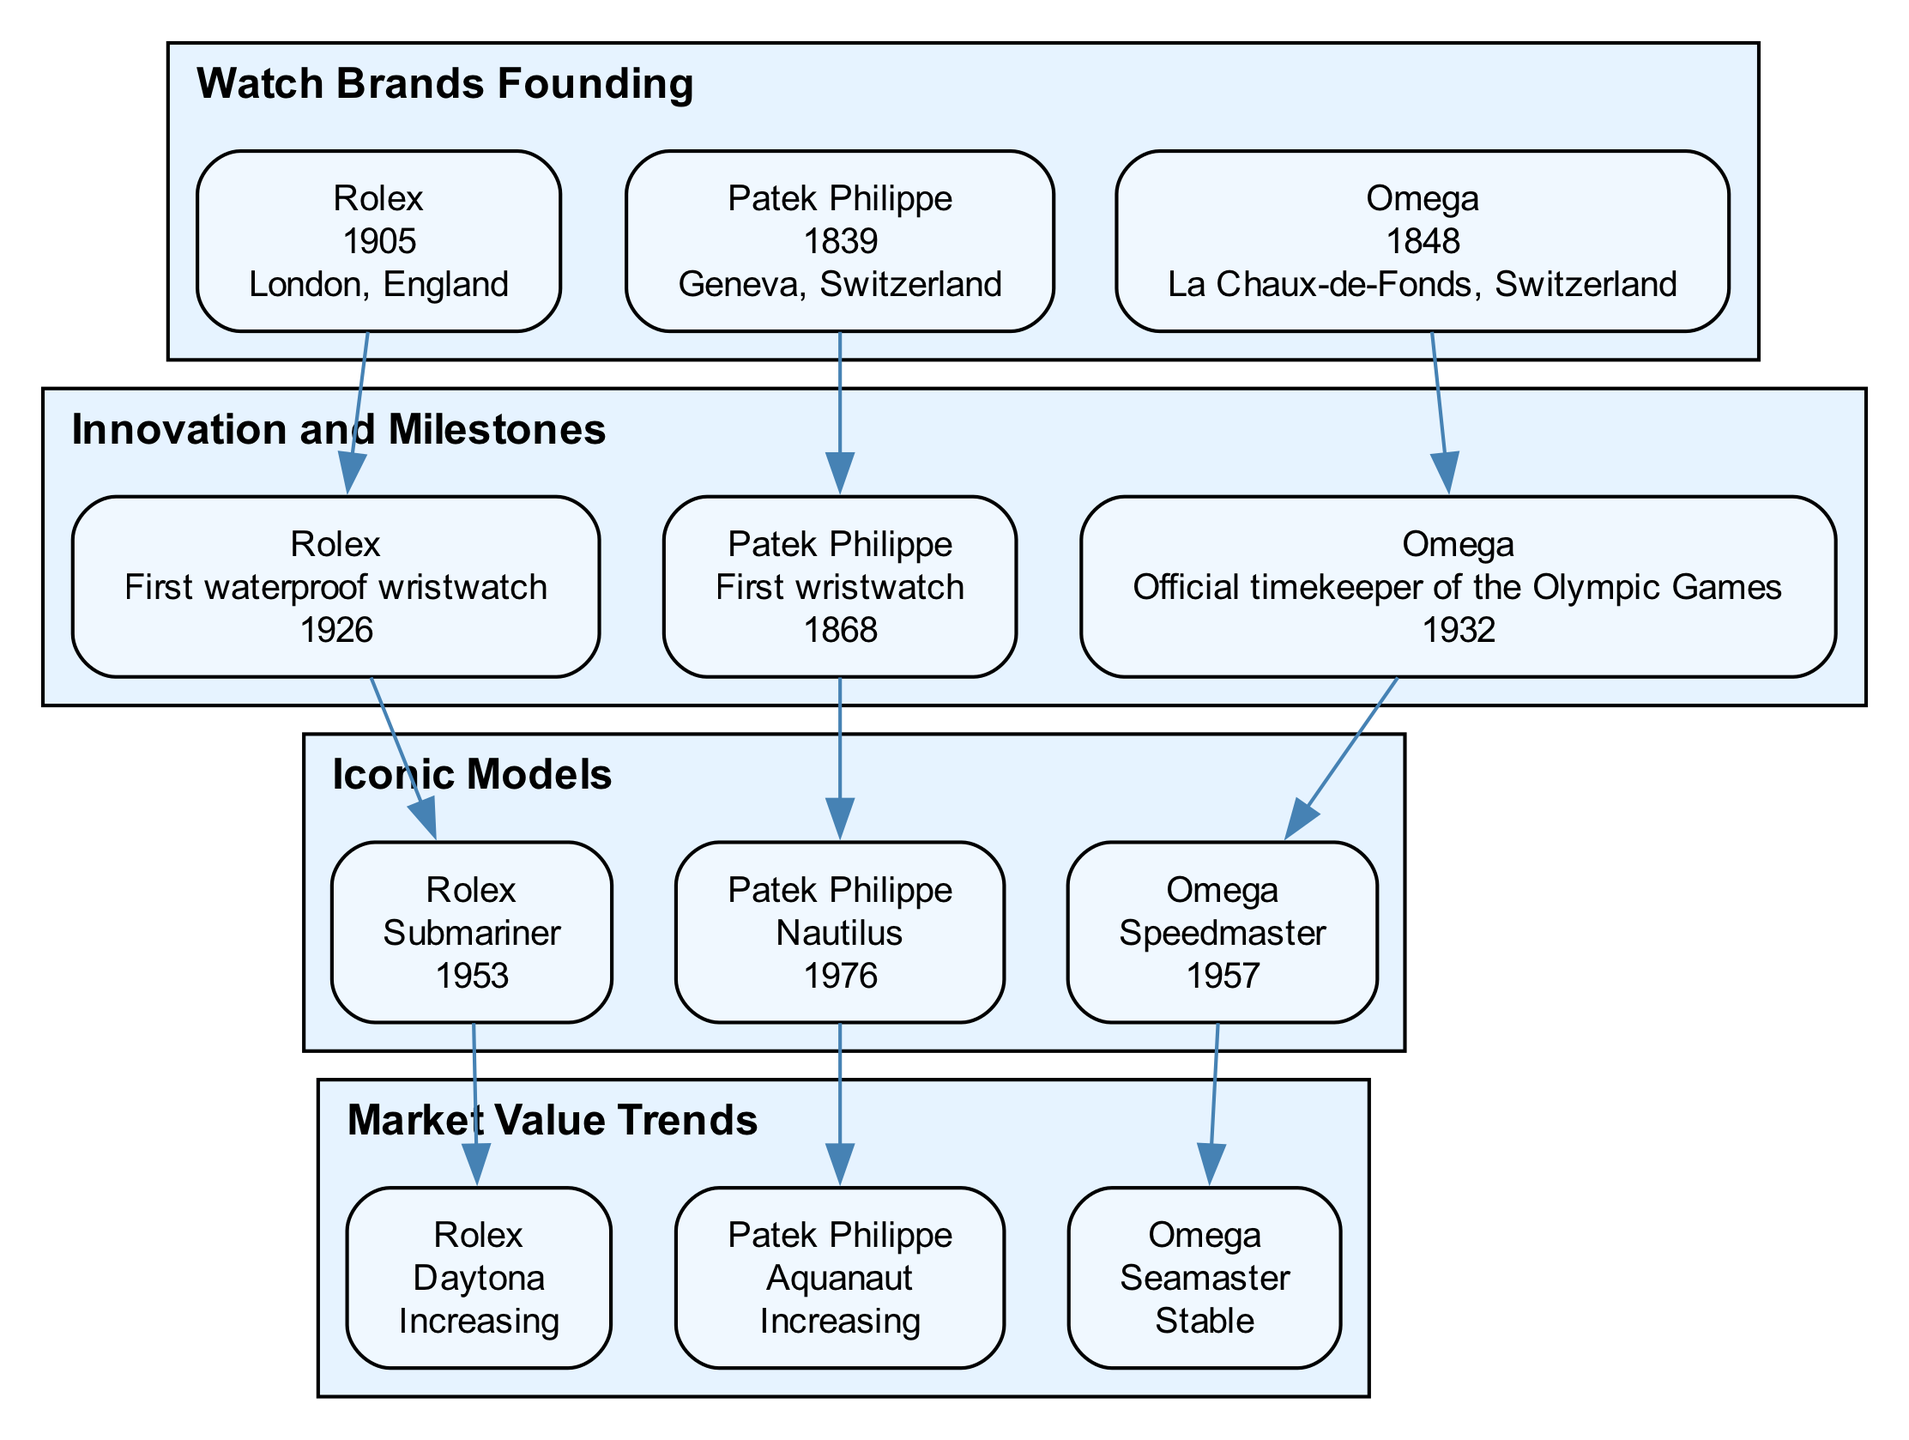What year was Rolex founded? By looking at the "Watch Brands Founding" block, Rolex's founding year is listed clearly next to its name. The diagram states that Rolex was founded in 1905.
Answer: 1905 What innovation did Patek Philippe introduce in 1868? In the "Innovation and Milestones" block, under Patek Philippe, it specifies the innovation as the "First wristwatch" and the corresponding year, which is 1868.
Answer: First wristwatch What model did Omega release in 1957? The "Iconic Models" block reveals that Omega's model released in 1957 is directly listed next to it, which is the "Speedmaster."
Answer: Speedmaster Which brand's iconic model has a market value trend listed as "Stable"? In the "Market Value Trends" block, looking at the listed brands and their models, Omega's "Seamaster" is noted with a stable market value, differentiating it from the others.
Answer: Seamaster How many brands are listed in the "Watch Brands Founding" block? By counting the entries shown in the "Watch Brands Founding" block, I see three brands: Rolex, Patek Philippe, and Omega. Therefore, there are a total of three brands mentioned.
Answer: 3 What significant role did Omega take on in 1932? The "Innovation and Milestones" block indicates that Omega became the "Official timekeeper of the Olympic Games" in 1932, providing its significant role historically.
Answer: Official timekeeper of the Olympic Games What is the market value trend for Rolex's Daytona in 2023? In the "Market Value Trends" block, Rolex's Daytona is shown with the market value marked as "Increasing," indicating positive growth in its value.
Answer: Increasing Which brand's iconic model is highlighted for release in 1976? In the "Iconic Models" block, Patek Philippe has its Nautilus model listed, and the release year of this model is noted as 1976.
Answer: Nautilus How are the nodes organized in the relationship between founding, innovation, models, and market value? The diagram shows a vertical flow (top to bottom) where each brand connects its founding information to innovations, then models, and finally market trends. This structure demonstrates the evolution of each brand in a stepwise manner.
Answer: Vertical flow 